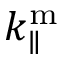<formula> <loc_0><loc_0><loc_500><loc_500>k _ { \| } ^ { m }</formula> 